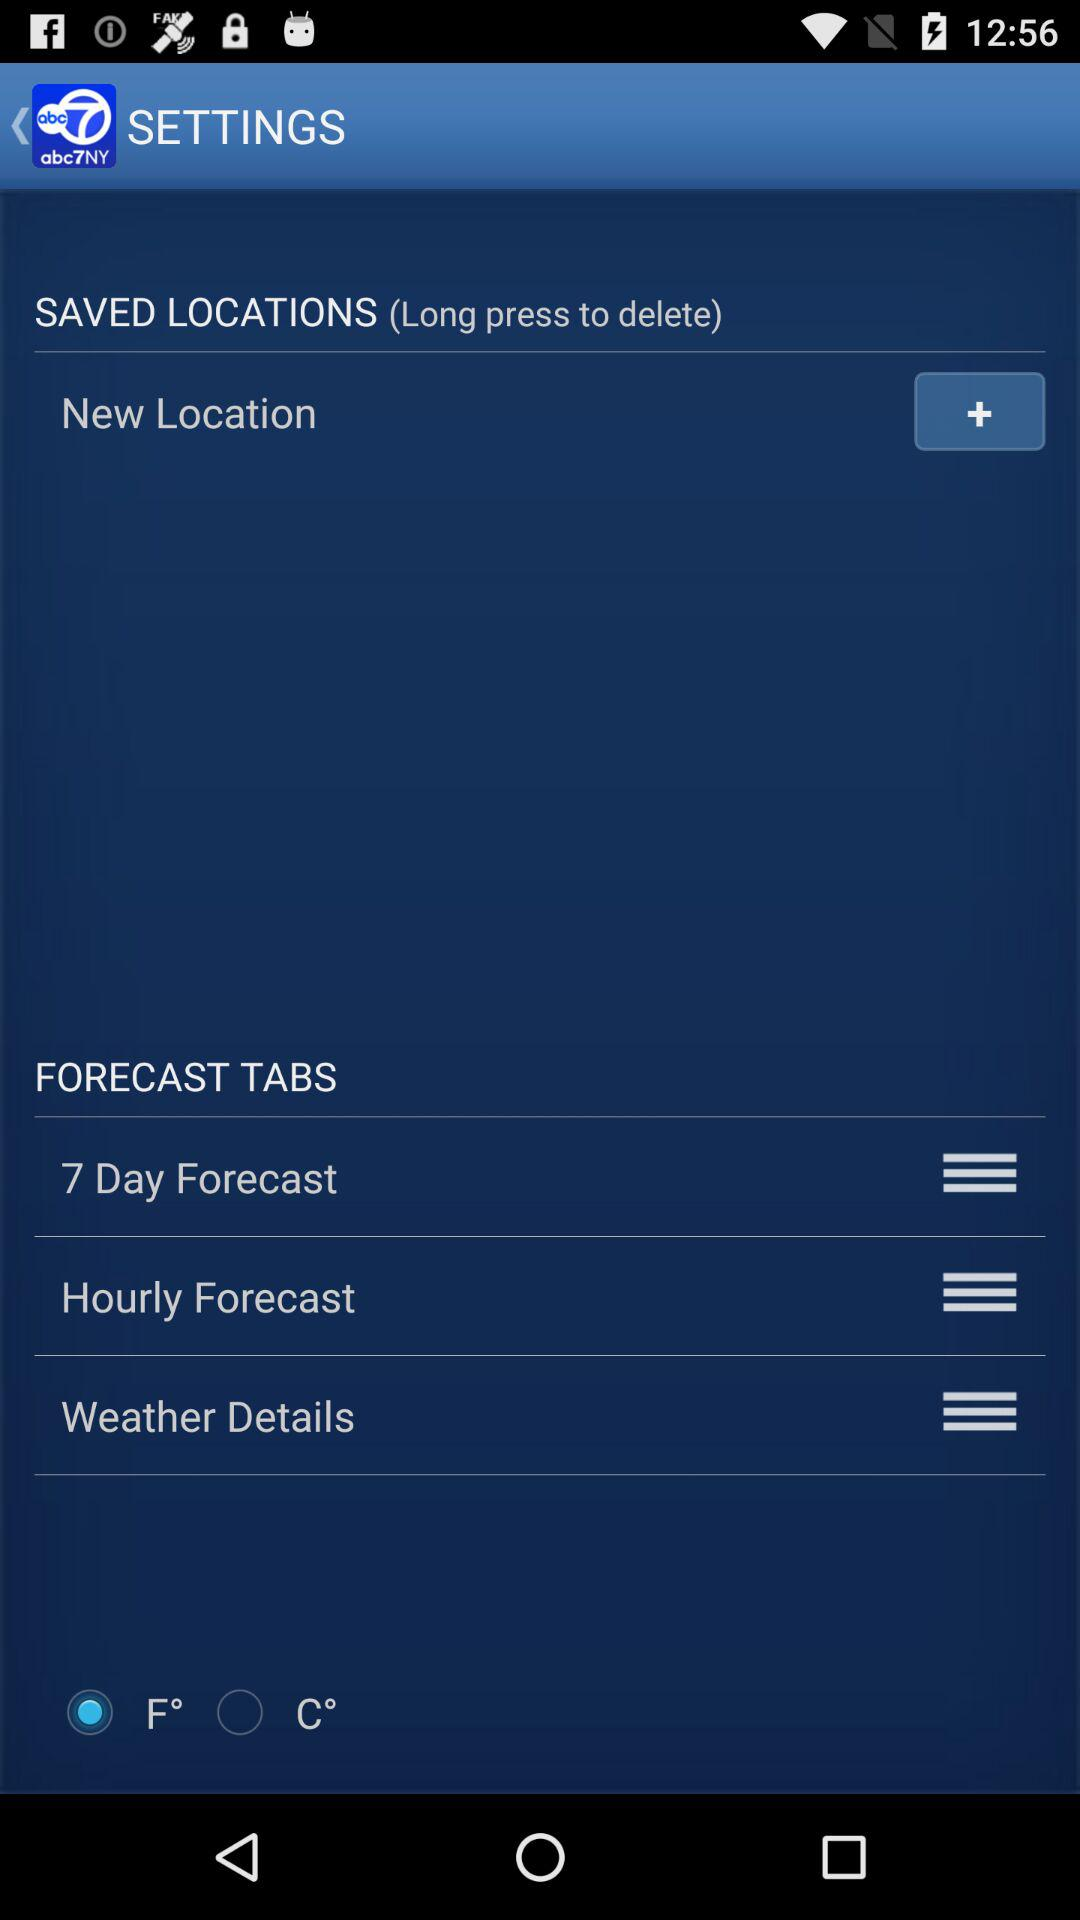What is the selected unit of temperature? The selected unit of temperature is F°. 